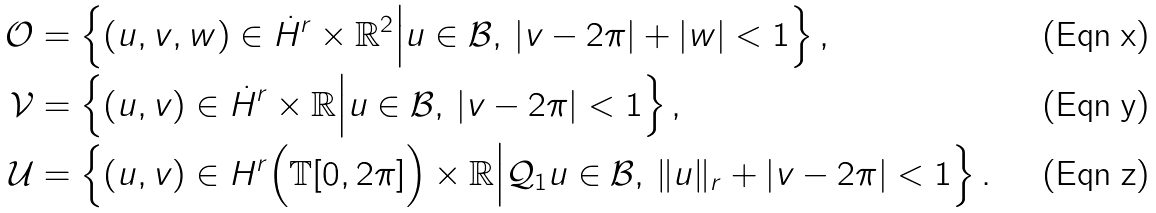Convert formula to latex. <formula><loc_0><loc_0><loc_500><loc_500>\mathcal { O } & = \left \{ ( u , v , w ) \in \dot { H } ^ { r } \times \mathbb { R } ^ { 2 } \Big | u \in \mathcal { B } , \, | v - 2 \pi | + | w | < 1 \right \} , \\ \mathcal { V } & = \left \{ ( u , v ) \in \dot { H } ^ { r } \times \mathbb { R } \Big | u \in \mathcal { B } , \, | v - 2 \pi | < 1 \right \} , \\ \mathcal { U } & = \left \{ ( u , v ) \in H ^ { r } \Big ( \mathbb { T } [ 0 , 2 \pi ] \Big ) \times \mathbb { R } \Big | \mathcal { Q } _ { 1 } u \in \mathcal { B } , \, \| u \| _ { r } + | v - 2 \pi | < 1 \right \} .</formula> 